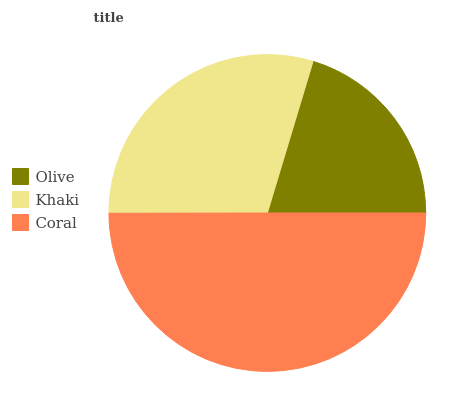Is Olive the minimum?
Answer yes or no. Yes. Is Coral the maximum?
Answer yes or no. Yes. Is Khaki the minimum?
Answer yes or no. No. Is Khaki the maximum?
Answer yes or no. No. Is Khaki greater than Olive?
Answer yes or no. Yes. Is Olive less than Khaki?
Answer yes or no. Yes. Is Olive greater than Khaki?
Answer yes or no. No. Is Khaki less than Olive?
Answer yes or no. No. Is Khaki the high median?
Answer yes or no. Yes. Is Khaki the low median?
Answer yes or no. Yes. Is Coral the high median?
Answer yes or no. No. Is Coral the low median?
Answer yes or no. No. 